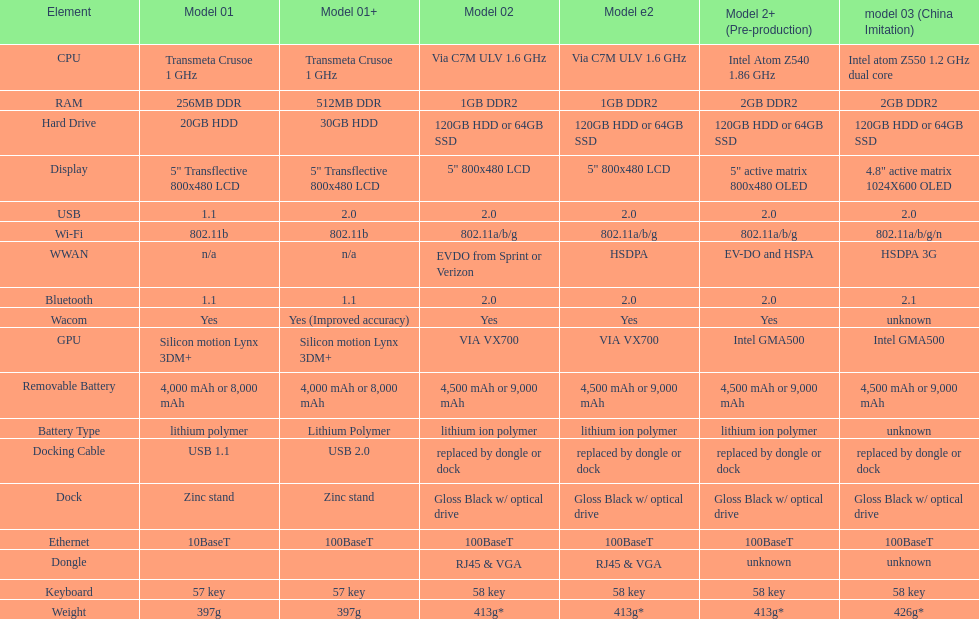What is the average number of models that have usb 2.0? 5. 